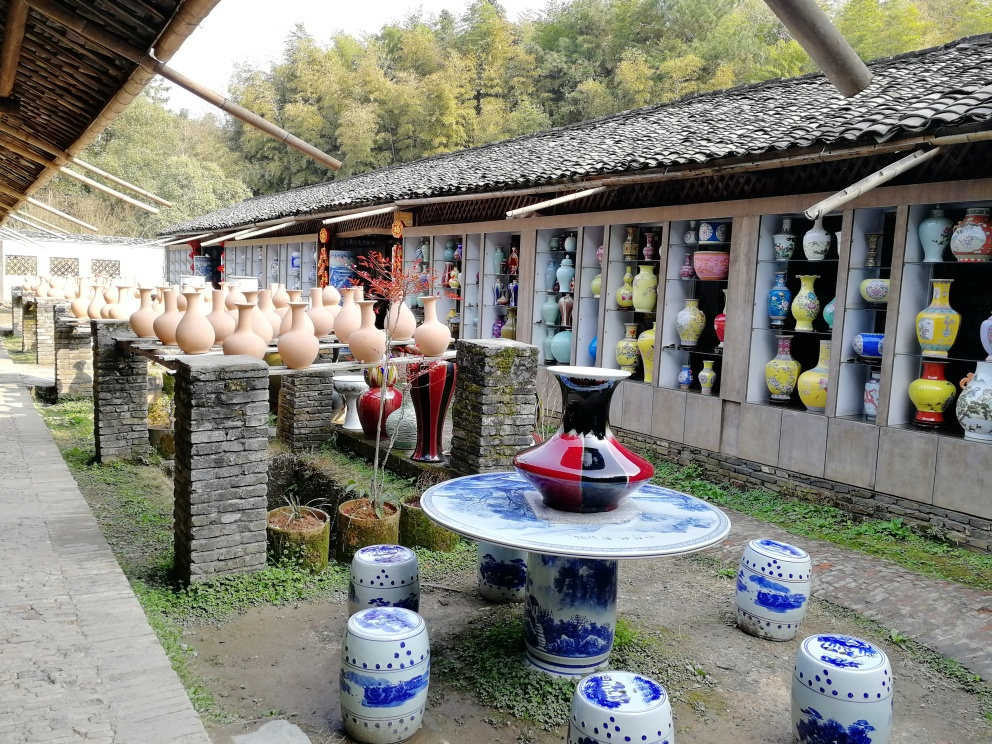Is there any motion blur in the photo?
A. No
B. Yes
Answer with the option's letter from the given choices directly.
 A. 